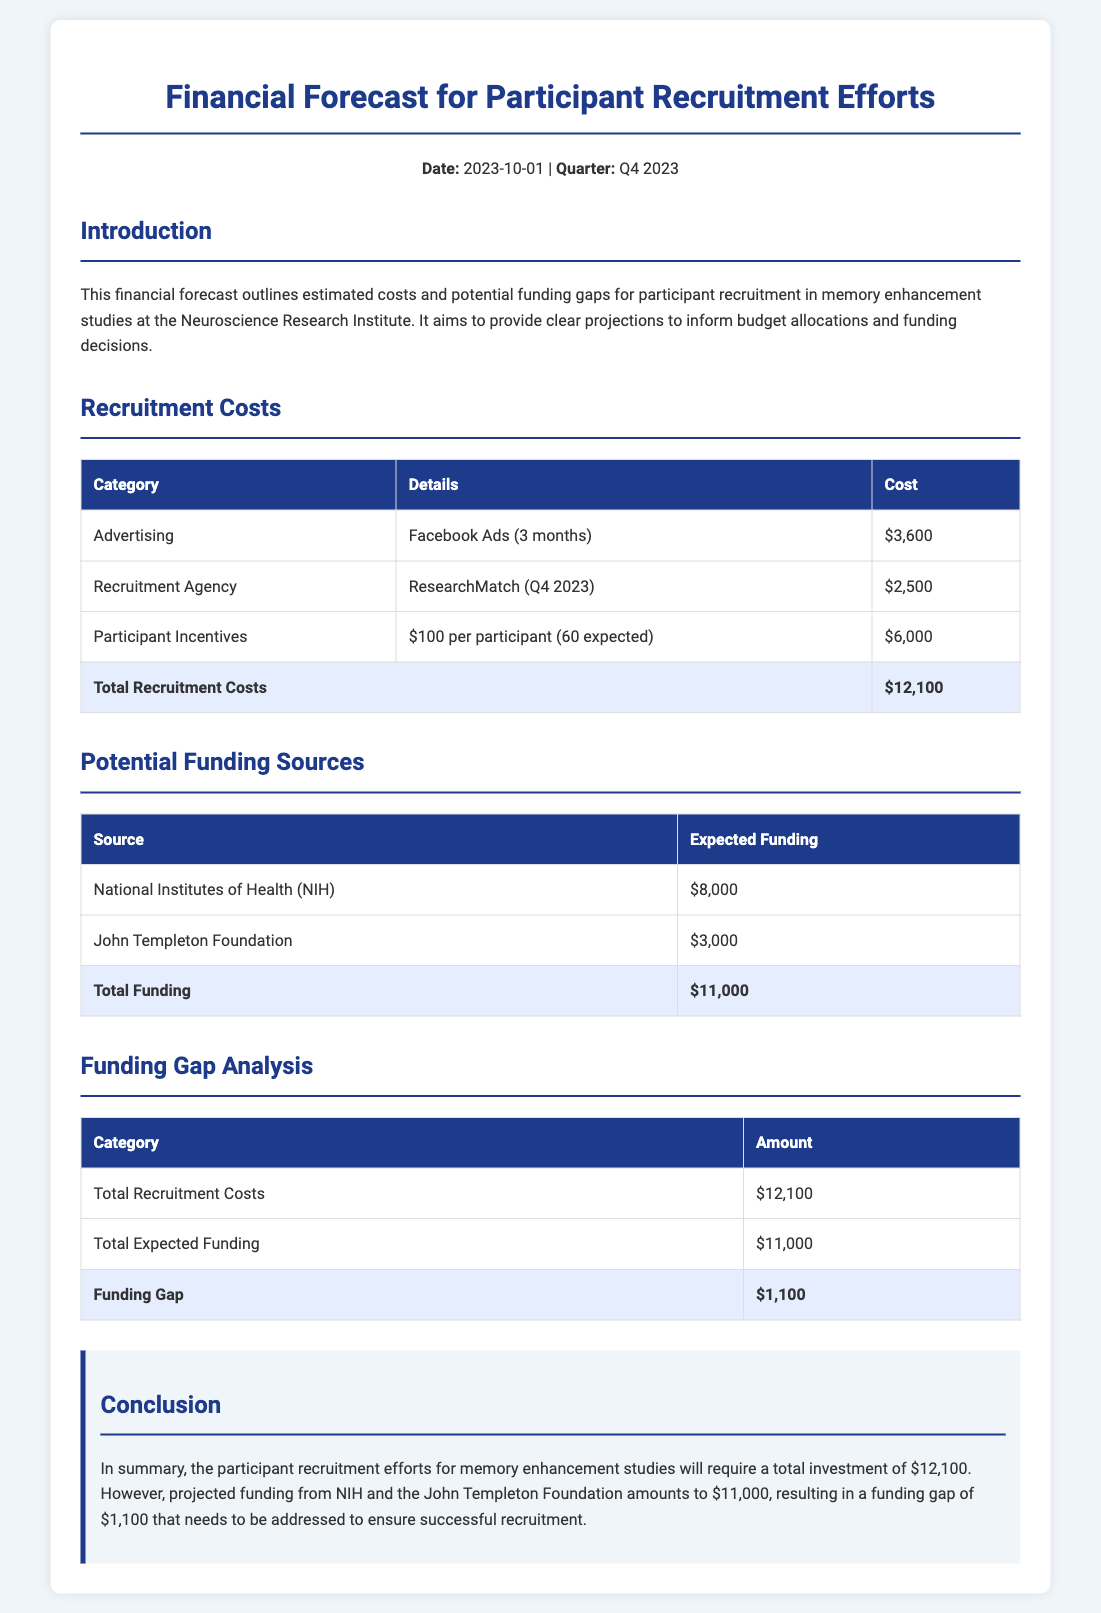What is the total recruitment cost? The total recruitment cost is highlighted in the document, which sums up all individual costs.
Answer: $12,100 What is the expected funding from the NIH? The document lists the expected funding from the NIH as one of the potential funding sources.
Answer: $8,000 How much is the funding gap? The funding gap is calculated by subtracting the total expected funding from the total recruitment costs.
Answer: $1,100 What is the cost of advertising for the recruitment? The document details the cost of advertising as part of the recruitment expenses.
Answer: $3,600 What total amount is expected from the John Templeton Foundation? The document specifies the expected funding amount from the John Templeton Foundation as a separate entry.
Answer: $3,000 What is the participant incentive amount per participant? The document outlines the incentive amount for each participant expected to be recruited.
Answer: $100 What quarter does this financial forecast cover? The document states the specific quarter that the financial forecast reflects.
Answer: Q4 2023 What is the total expected funding? The total expected funding is calculated and presented from all funding sources listed in the document.
Answer: $11,000 